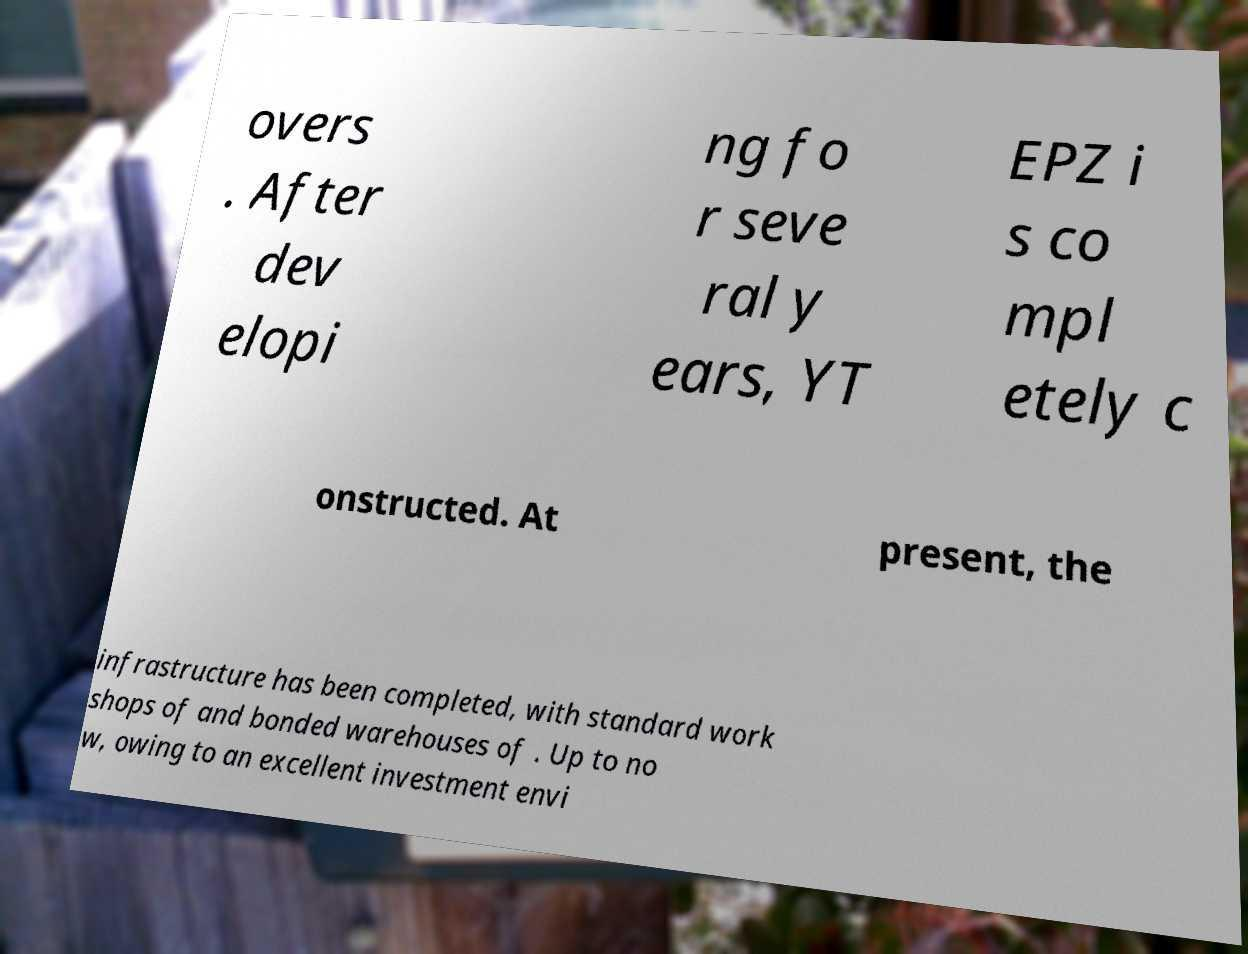Can you accurately transcribe the text from the provided image for me? overs . After dev elopi ng fo r seve ral y ears, YT EPZ i s co mpl etely c onstructed. At present, the infrastructure has been completed, with standard work shops of and bonded warehouses of . Up to no w, owing to an excellent investment envi 